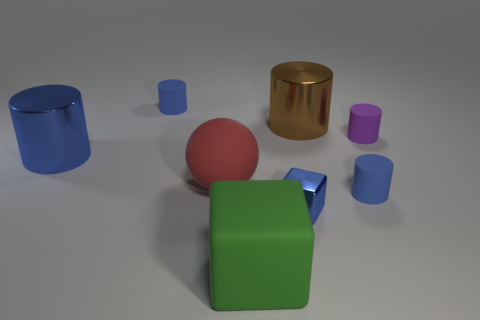Do the matte cylinder to the left of the large brown metal cylinder and the tiny metal block have the same color?
Your answer should be very brief. Yes. The brown cylinder has what size?
Give a very brief answer. Large. What material is the blue thing that is the same size as the brown thing?
Ensure brevity in your answer.  Metal. What is the color of the large shiny cylinder left of the tiny blue metallic thing?
Provide a succinct answer. Blue. How many metal objects are there?
Make the answer very short. 3. Is there a large blue metal thing to the left of the tiny blue matte thing in front of the large metal object in front of the small purple object?
Make the answer very short. Yes. What is the shape of the green thing that is the same size as the red thing?
Provide a short and direct response. Cube. What number of other objects are there of the same color as the large rubber ball?
Your response must be concise. 0. What is the material of the big sphere?
Offer a terse response. Rubber. How many other things are there of the same material as the tiny block?
Make the answer very short. 2. 